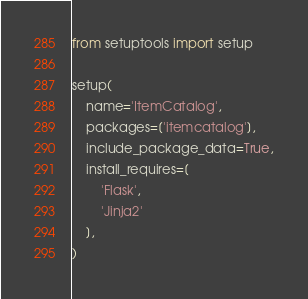<code> <loc_0><loc_0><loc_500><loc_500><_Python_>from setuptools import setup

setup(
    name='ItemCatalog',
    packages=['itemcatalog'],
    include_package_data=True,
    install_requires=[
        'Flask',
        'Jinja2'
    ],
)
</code> 